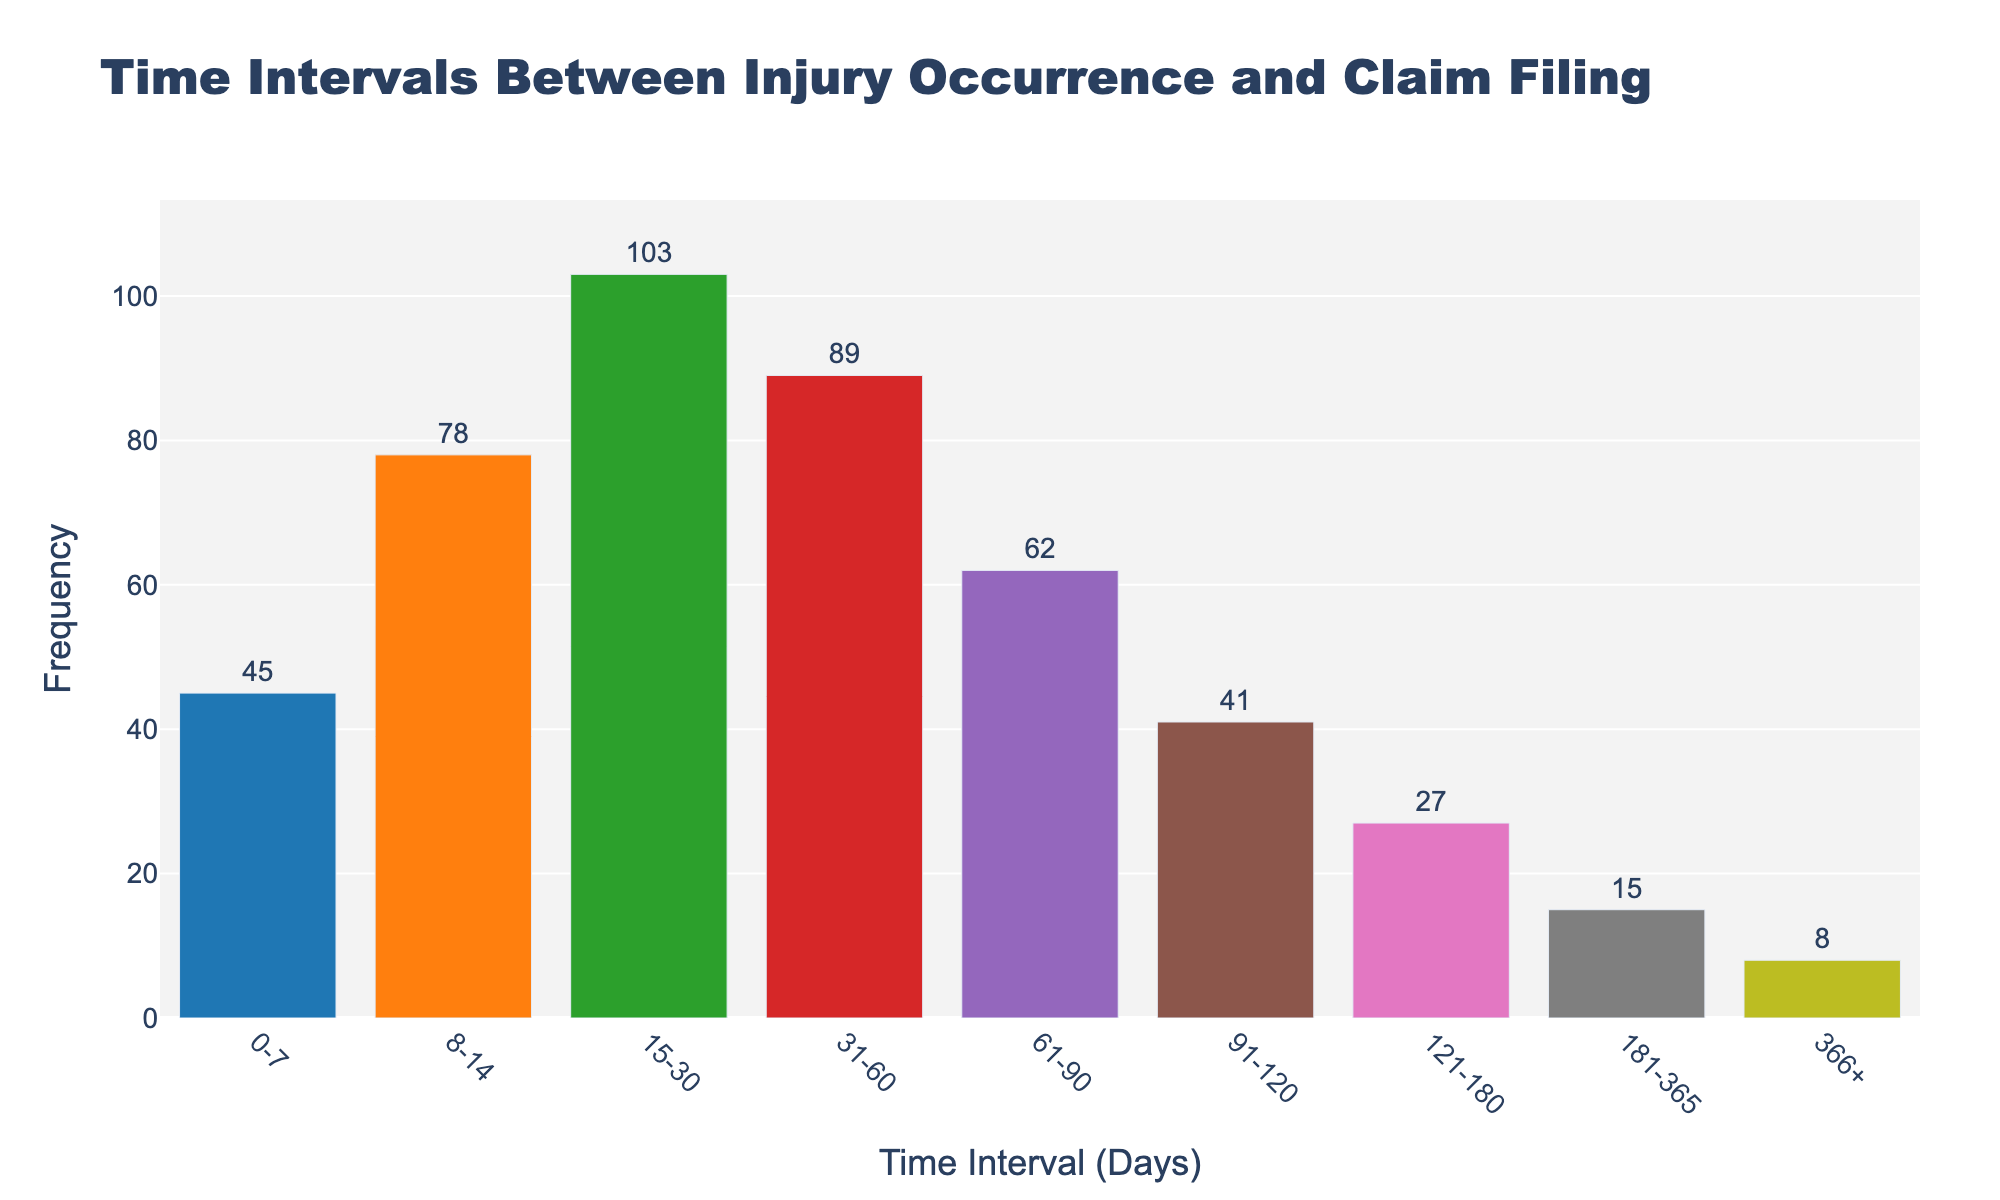what is the title of the figure? The title of the figure is displayed at the top and provides a summary of what the figure represents. The title is "Time Intervals Between Injury Occurrence and Claim Filing".
Answer: Time Intervals Between Injury Occurrence and Claim Filing What is the time interval with the highest frequency? To determine the time interval with the highest frequency, look at the bars in the histogram and find the one that extends the furthest upwards. The interval with the highest frequency is "15-30 days" which reaches a frequency of 103.
Answer: 15-30 days How many claims were filed within 30 days? To find out the number of claims filed within 30 days, add the frequencies of the intervals from "0-7", "8-14", and "15-30". The sum is 45 + 78 + 103 = 226.
Answer: 226 Which time interval has the lowest frequency? The lowest frequency corresponds to the interval with the shortest bar. In this histogram, the interval "366+" has the fewest number of claims filed, with a frequency of 8.
Answer: 366+ How does the frequency of claims filed within 61-90 days compare to those filed within 121-180 days? Compare the heights of the bars for "61-90" days (which has a frequency of 62) and "121-180" days (which has a frequency of 27). The frequency for "61-90" days is higher than for "121-180" days.
Answer: Higher What is the combined frequency for claims filed between 91 and 365 days? To find the combined frequency, sum the frequencies for "91-120", "121-180", "181-365". The calculation is 41 + 27 + 15 = 83.
Answer: 83 Between which pairs of time intervals does the largest drop in frequency occur? Identify the largest drop by comparing the differences in heights of consecutive bars. The largest drop occurs between "15-30" (103) and "31-60" (89), calculating the difference as 103 - 89 = 14.
Answer: 15-30 and 31-60 What can be inferred about the trend in claim filings relative to time intervals? Observe the general trend of the bar heights. The frequency of claims tends to decline as the time interval increases, indicating that most claims are filed shortly after injuries.
Answer: Frequency declines as time interval increases What percentage of claims were filed within the first 90 days? To determine this, first find the total number of claims by adding all frequencies: 45 + 78 + 103 + 89 + 62 + 41 + 27 + 15 + 8 = 468. Then, sum the frequencies for the first 90 days: 45 + 78 + 103 + 89 + 62 = 377. The percentage is calculated as (377 / 468) * 100 ≈ 80.55%.
Answer: 80.55% What is the approximate ratio of claims filed within 8-14 days to those filed within 31-60 days? Identify the frequencies for the intervals "8-14" (78) and "31-60" (89). The ratio is calculated as 78:89, which simplifies approximately to 0.88:1.
Answer: 0.88:1 